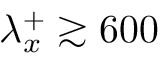Convert formula to latex. <formula><loc_0><loc_0><loc_500><loc_500>\lambda _ { x } ^ { + } \gtrsim 6 0 0</formula> 